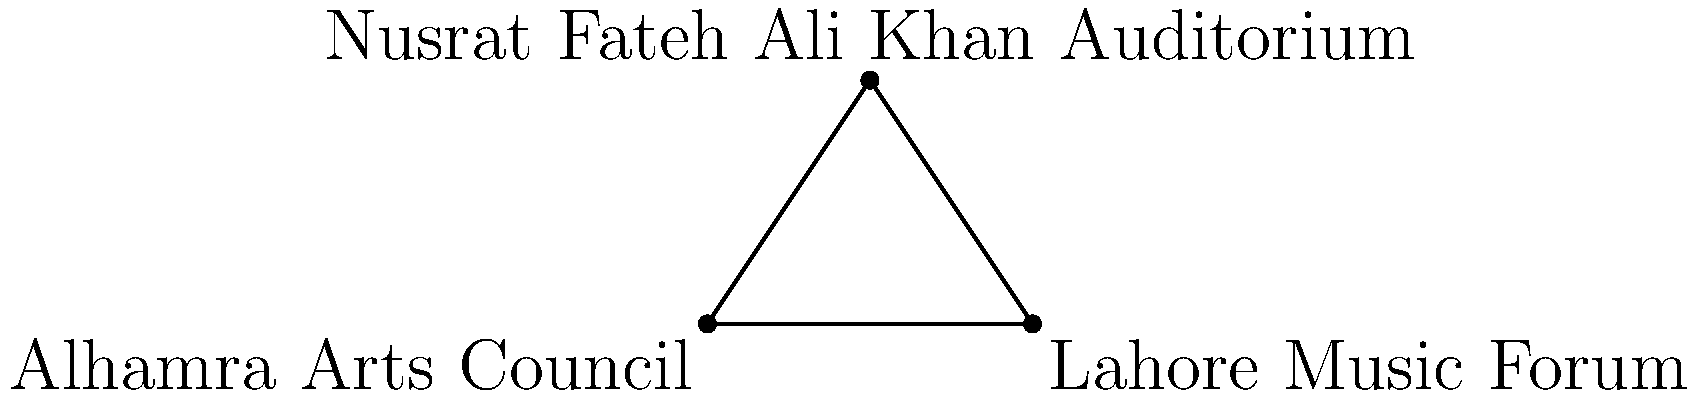Three significant locations in Lahore's music scene form a triangle on a coordinate plane: Alhamra Arts Council at (0,0), Lahore Music Forum at (8,0), and Nusrat Fateh Ali Khan Auditorium at (4,6). Calculate the area of the triangle formed by these locations. To find the area of the triangle, we can use the formula:

Area = $\frac{1}{2}|x_1(y_2 - y_3) + x_2(y_3 - y_1) + x_3(y_1 - y_2)|$

Where $(x_1, y_1)$, $(x_2, y_2)$, and $(x_3, y_3)$ are the coordinates of the three points.

Let's assign the coordinates:
Alhamra Arts Council: $(x_1, y_1) = (0, 0)$
Lahore Music Forum: $(x_2, y_2) = (8, 0)$
Nusrat Fateh Ali Khan Auditorium: $(x_3, y_3) = (4, 6)$

Now, let's substitute these values into the formula:

Area = $\frac{1}{2}|0(0 - 6) + 8(6 - 0) + 4(0 - 0)|$
     = $\frac{1}{2}|0 + 48 + 0|$
     = $\frac{1}{2}(48)$
     = $24$

Therefore, the area of the triangle is 24 square units.
Answer: 24 square units 